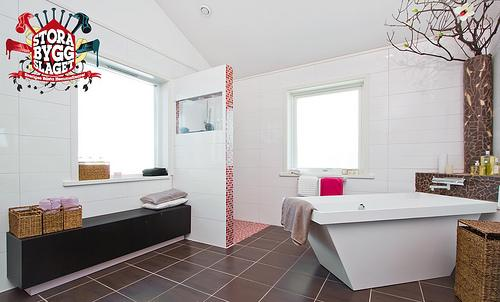How many wicket baskets are on top of the little bench near the doorway? three 